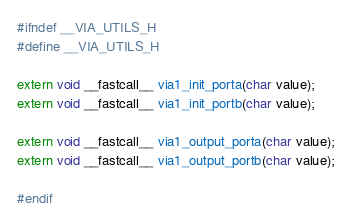Convert code to text. <code><loc_0><loc_0><loc_500><loc_500><_C_>#ifndef __VIA_UTILS_H
#define __VIA_UTILS_H

extern void __fastcall__ via1_init_porta(char value);
extern void __fastcall__ via1_init_portb(char value);

extern void __fastcall__ via1_output_porta(char value);
extern void __fastcall__ via1_output_portb(char value);

#endif
</code> 